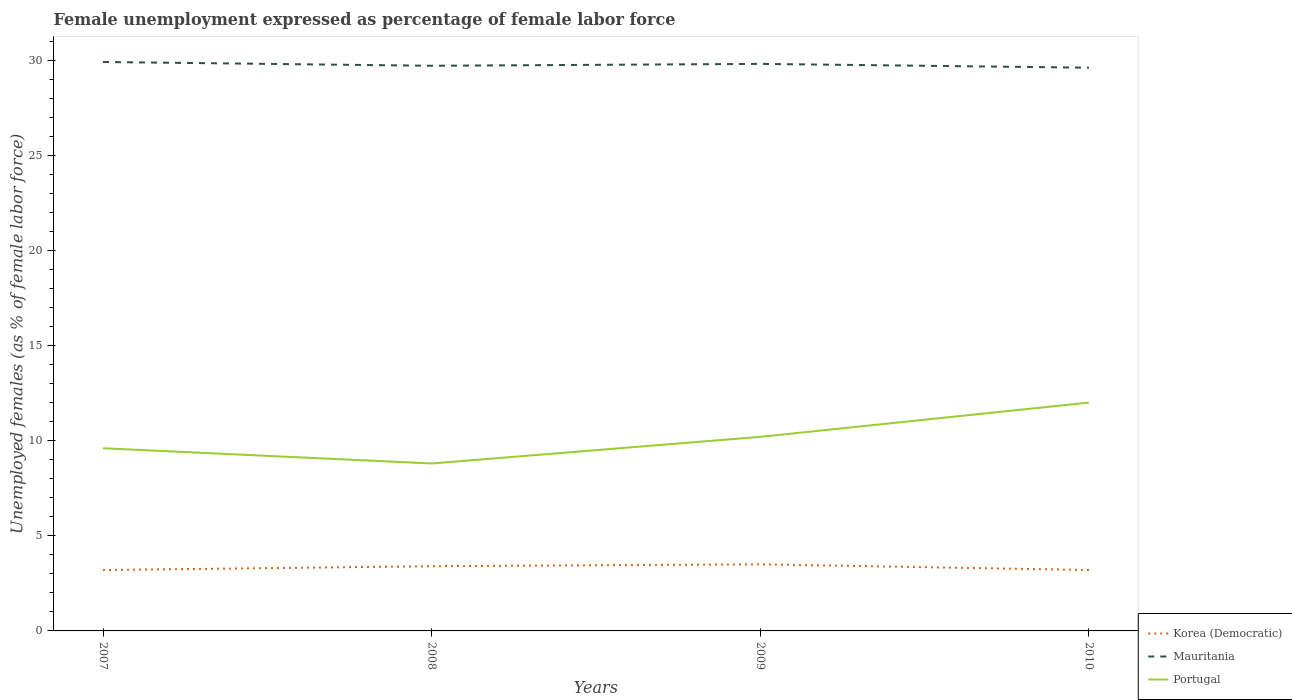Is the number of lines equal to the number of legend labels?
Offer a terse response. Yes. Across all years, what is the maximum unemployment in females in in Mauritania?
Your answer should be compact. 29.6. What is the total unemployment in females in in Portugal in the graph?
Offer a terse response. -1.8. What is the difference between the highest and the second highest unemployment in females in in Portugal?
Offer a terse response. 3.2. How many years are there in the graph?
Give a very brief answer. 4. What is the difference between two consecutive major ticks on the Y-axis?
Offer a very short reply. 5. Does the graph contain grids?
Keep it short and to the point. No. Where does the legend appear in the graph?
Offer a very short reply. Bottom right. How many legend labels are there?
Provide a short and direct response. 3. What is the title of the graph?
Your answer should be compact. Female unemployment expressed as percentage of female labor force. What is the label or title of the Y-axis?
Give a very brief answer. Unemployed females (as % of female labor force). What is the Unemployed females (as % of female labor force) of Korea (Democratic) in 2007?
Provide a succinct answer. 3.2. What is the Unemployed females (as % of female labor force) in Mauritania in 2007?
Your answer should be compact. 29.9. What is the Unemployed females (as % of female labor force) of Portugal in 2007?
Ensure brevity in your answer.  9.6. What is the Unemployed females (as % of female labor force) in Korea (Democratic) in 2008?
Offer a terse response. 3.4. What is the Unemployed females (as % of female labor force) in Mauritania in 2008?
Your answer should be very brief. 29.7. What is the Unemployed females (as % of female labor force) of Portugal in 2008?
Keep it short and to the point. 8.8. What is the Unemployed females (as % of female labor force) of Korea (Democratic) in 2009?
Provide a succinct answer. 3.5. What is the Unemployed females (as % of female labor force) of Mauritania in 2009?
Provide a succinct answer. 29.8. What is the Unemployed females (as % of female labor force) of Portugal in 2009?
Ensure brevity in your answer.  10.2. What is the Unemployed females (as % of female labor force) in Korea (Democratic) in 2010?
Provide a succinct answer. 3.2. What is the Unemployed females (as % of female labor force) in Mauritania in 2010?
Your response must be concise. 29.6. Across all years, what is the maximum Unemployed females (as % of female labor force) of Mauritania?
Offer a terse response. 29.9. Across all years, what is the minimum Unemployed females (as % of female labor force) of Korea (Democratic)?
Provide a short and direct response. 3.2. Across all years, what is the minimum Unemployed females (as % of female labor force) in Mauritania?
Offer a very short reply. 29.6. Across all years, what is the minimum Unemployed females (as % of female labor force) of Portugal?
Your answer should be compact. 8.8. What is the total Unemployed females (as % of female labor force) in Mauritania in the graph?
Your answer should be very brief. 119. What is the total Unemployed females (as % of female labor force) of Portugal in the graph?
Your answer should be very brief. 40.6. What is the difference between the Unemployed females (as % of female labor force) of Korea (Democratic) in 2007 and that in 2008?
Provide a succinct answer. -0.2. What is the difference between the Unemployed females (as % of female labor force) of Mauritania in 2007 and that in 2008?
Your answer should be very brief. 0.2. What is the difference between the Unemployed females (as % of female labor force) of Mauritania in 2007 and that in 2009?
Your answer should be very brief. 0.1. What is the difference between the Unemployed females (as % of female labor force) in Korea (Democratic) in 2007 and that in 2010?
Your answer should be very brief. 0. What is the difference between the Unemployed females (as % of female labor force) in Mauritania in 2007 and that in 2010?
Your response must be concise. 0.3. What is the difference between the Unemployed females (as % of female labor force) of Portugal in 2007 and that in 2010?
Give a very brief answer. -2.4. What is the difference between the Unemployed females (as % of female labor force) in Korea (Democratic) in 2008 and that in 2009?
Ensure brevity in your answer.  -0.1. What is the difference between the Unemployed females (as % of female labor force) in Portugal in 2008 and that in 2009?
Provide a succinct answer. -1.4. What is the difference between the Unemployed females (as % of female labor force) of Korea (Democratic) in 2007 and the Unemployed females (as % of female labor force) of Mauritania in 2008?
Ensure brevity in your answer.  -26.5. What is the difference between the Unemployed females (as % of female labor force) in Mauritania in 2007 and the Unemployed females (as % of female labor force) in Portugal in 2008?
Offer a terse response. 21.1. What is the difference between the Unemployed females (as % of female labor force) of Korea (Democratic) in 2007 and the Unemployed females (as % of female labor force) of Mauritania in 2009?
Provide a succinct answer. -26.6. What is the difference between the Unemployed females (as % of female labor force) of Mauritania in 2007 and the Unemployed females (as % of female labor force) of Portugal in 2009?
Give a very brief answer. 19.7. What is the difference between the Unemployed females (as % of female labor force) of Korea (Democratic) in 2007 and the Unemployed females (as % of female labor force) of Mauritania in 2010?
Provide a short and direct response. -26.4. What is the difference between the Unemployed females (as % of female labor force) of Mauritania in 2007 and the Unemployed females (as % of female labor force) of Portugal in 2010?
Your answer should be compact. 17.9. What is the difference between the Unemployed females (as % of female labor force) of Korea (Democratic) in 2008 and the Unemployed females (as % of female labor force) of Mauritania in 2009?
Make the answer very short. -26.4. What is the difference between the Unemployed females (as % of female labor force) in Korea (Democratic) in 2008 and the Unemployed females (as % of female labor force) in Portugal in 2009?
Make the answer very short. -6.8. What is the difference between the Unemployed females (as % of female labor force) in Korea (Democratic) in 2008 and the Unemployed females (as % of female labor force) in Mauritania in 2010?
Keep it short and to the point. -26.2. What is the difference between the Unemployed females (as % of female labor force) of Mauritania in 2008 and the Unemployed females (as % of female labor force) of Portugal in 2010?
Provide a short and direct response. 17.7. What is the difference between the Unemployed females (as % of female labor force) in Korea (Democratic) in 2009 and the Unemployed females (as % of female labor force) in Mauritania in 2010?
Your answer should be compact. -26.1. What is the difference between the Unemployed females (as % of female labor force) in Korea (Democratic) in 2009 and the Unemployed females (as % of female labor force) in Portugal in 2010?
Your answer should be compact. -8.5. What is the average Unemployed females (as % of female labor force) in Korea (Democratic) per year?
Make the answer very short. 3.33. What is the average Unemployed females (as % of female labor force) in Mauritania per year?
Offer a terse response. 29.75. What is the average Unemployed females (as % of female labor force) in Portugal per year?
Provide a short and direct response. 10.15. In the year 2007, what is the difference between the Unemployed females (as % of female labor force) of Korea (Democratic) and Unemployed females (as % of female labor force) of Mauritania?
Make the answer very short. -26.7. In the year 2007, what is the difference between the Unemployed females (as % of female labor force) of Mauritania and Unemployed females (as % of female labor force) of Portugal?
Keep it short and to the point. 20.3. In the year 2008, what is the difference between the Unemployed females (as % of female labor force) of Korea (Democratic) and Unemployed females (as % of female labor force) of Mauritania?
Offer a very short reply. -26.3. In the year 2008, what is the difference between the Unemployed females (as % of female labor force) of Mauritania and Unemployed females (as % of female labor force) of Portugal?
Offer a very short reply. 20.9. In the year 2009, what is the difference between the Unemployed females (as % of female labor force) in Korea (Democratic) and Unemployed females (as % of female labor force) in Mauritania?
Make the answer very short. -26.3. In the year 2009, what is the difference between the Unemployed females (as % of female labor force) of Korea (Democratic) and Unemployed females (as % of female labor force) of Portugal?
Offer a very short reply. -6.7. In the year 2009, what is the difference between the Unemployed females (as % of female labor force) in Mauritania and Unemployed females (as % of female labor force) in Portugal?
Keep it short and to the point. 19.6. In the year 2010, what is the difference between the Unemployed females (as % of female labor force) of Korea (Democratic) and Unemployed females (as % of female labor force) of Mauritania?
Make the answer very short. -26.4. What is the ratio of the Unemployed females (as % of female labor force) in Korea (Democratic) in 2007 to that in 2009?
Offer a terse response. 0.91. What is the ratio of the Unemployed females (as % of female labor force) in Mauritania in 2007 to that in 2009?
Offer a terse response. 1. What is the ratio of the Unemployed females (as % of female labor force) in Korea (Democratic) in 2007 to that in 2010?
Your response must be concise. 1. What is the ratio of the Unemployed females (as % of female labor force) in Portugal in 2007 to that in 2010?
Ensure brevity in your answer.  0.8. What is the ratio of the Unemployed females (as % of female labor force) of Korea (Democratic) in 2008 to that in 2009?
Your answer should be very brief. 0.97. What is the ratio of the Unemployed females (as % of female labor force) of Portugal in 2008 to that in 2009?
Make the answer very short. 0.86. What is the ratio of the Unemployed females (as % of female labor force) of Korea (Democratic) in 2008 to that in 2010?
Your answer should be very brief. 1.06. What is the ratio of the Unemployed females (as % of female labor force) in Mauritania in 2008 to that in 2010?
Keep it short and to the point. 1. What is the ratio of the Unemployed females (as % of female labor force) in Portugal in 2008 to that in 2010?
Provide a short and direct response. 0.73. What is the ratio of the Unemployed females (as % of female labor force) in Korea (Democratic) in 2009 to that in 2010?
Provide a succinct answer. 1.09. What is the ratio of the Unemployed females (as % of female labor force) in Mauritania in 2009 to that in 2010?
Offer a terse response. 1.01. What is the difference between the highest and the second highest Unemployed females (as % of female labor force) of Mauritania?
Keep it short and to the point. 0.1. What is the difference between the highest and the lowest Unemployed females (as % of female labor force) in Korea (Democratic)?
Ensure brevity in your answer.  0.3. What is the difference between the highest and the lowest Unemployed females (as % of female labor force) in Portugal?
Make the answer very short. 3.2. 